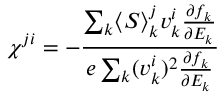Convert formula to latex. <formula><loc_0><loc_0><loc_500><loc_500>\chi ^ { j i } = - \frac { \sum _ { k } \langle S \rangle _ { k } ^ { j } v _ { k } ^ { i } \frac { \partial f _ { k } } { \partial E _ { k } } } { e \sum _ { k } ( v _ { k } ^ { i } ) ^ { 2 } \frac { \partial f _ { k } } { \partial E _ { k } } }</formula> 